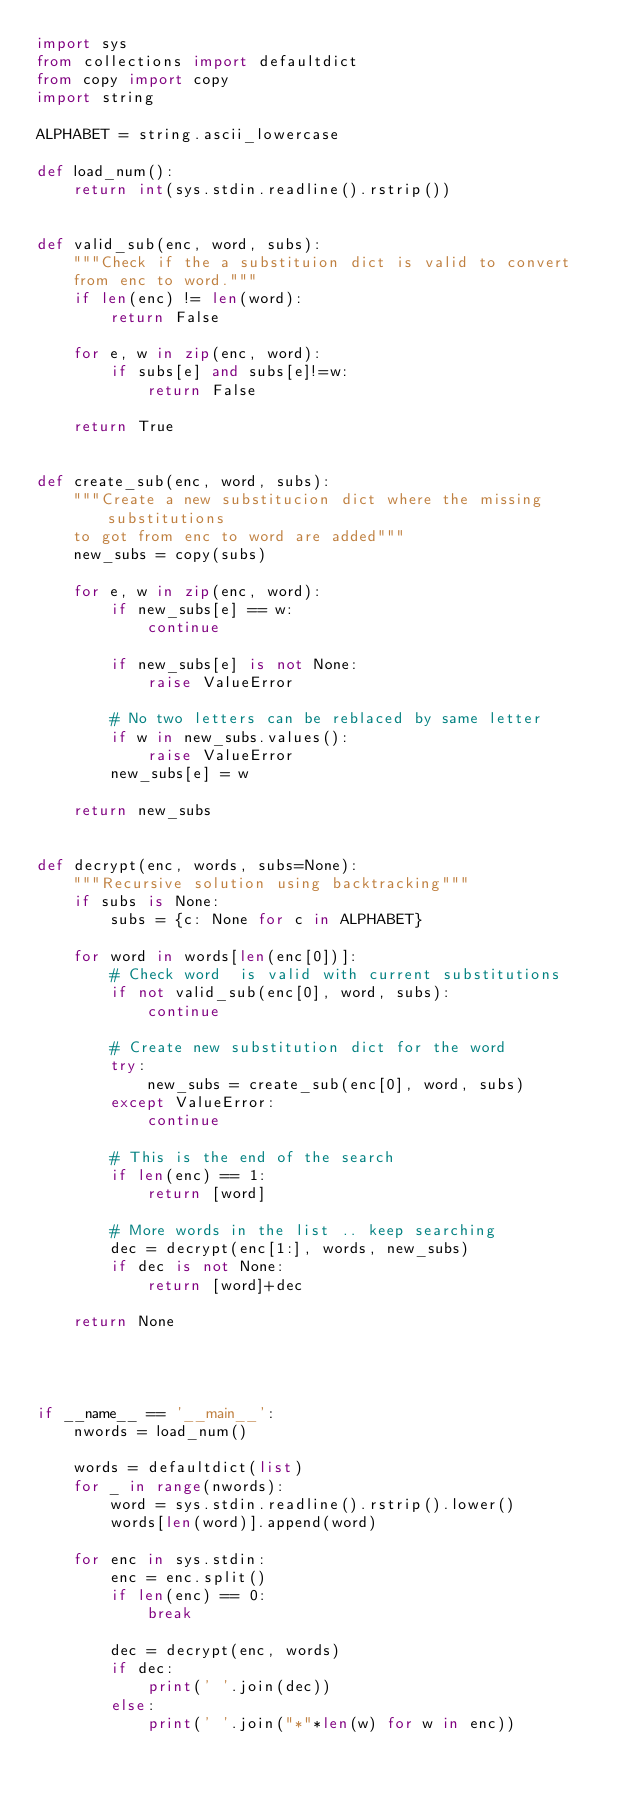Convert code to text. <code><loc_0><loc_0><loc_500><loc_500><_Python_>import sys
from collections import defaultdict
from copy import copy
import string

ALPHABET = string.ascii_lowercase

def load_num():
    return int(sys.stdin.readline().rstrip())


def valid_sub(enc, word, subs):
    """Check if the a substituion dict is valid to convert
    from enc to word."""
    if len(enc) != len(word):
        return False

    for e, w in zip(enc, word):
        if subs[e] and subs[e]!=w: 
            return False

    return True


def create_sub(enc, word, subs):
    """Create a new substitucion dict where the missing substitutions
    to got from enc to word are added"""
    new_subs = copy(subs)

    for e, w in zip(enc, word):
        if new_subs[e] == w:
            continue

        if new_subs[e] is not None:
            raise ValueError

        # No two letters can be reblaced by same letter
        if w in new_subs.values():
            raise ValueError
        new_subs[e] = w
    
    return new_subs


def decrypt(enc, words, subs=None):
    """Recursive solution using backtracking"""
    if subs is None:
        subs = {c: None for c in ALPHABET}

    for word in words[len(enc[0])]:
        # Check word  is valid with current substitutions
        if not valid_sub(enc[0], word, subs):
            continue

        # Create new substitution dict for the word
        try:
            new_subs = create_sub(enc[0], word, subs)
        except ValueError:
            continue
 
        # This is the end of the search
        if len(enc) == 1:
            return [word]
        
        # More words in the list .. keep searching
        dec = decrypt(enc[1:], words, new_subs)
        if dec is not None:
            return [word]+dec
        
    return None




if __name__ == '__main__':
    nwords = load_num()
    
    words = defaultdict(list)
    for _ in range(nwords):
        word = sys.stdin.readline().rstrip().lower()
        words[len(word)].append(word)

    for enc in sys.stdin:
        enc = enc.split()
        if len(enc) == 0:
            break

        dec = decrypt(enc, words)
        if dec:
            print(' '.join(dec))
        else:        
            print(' '.join("*"*len(w) for w in enc))

</code> 